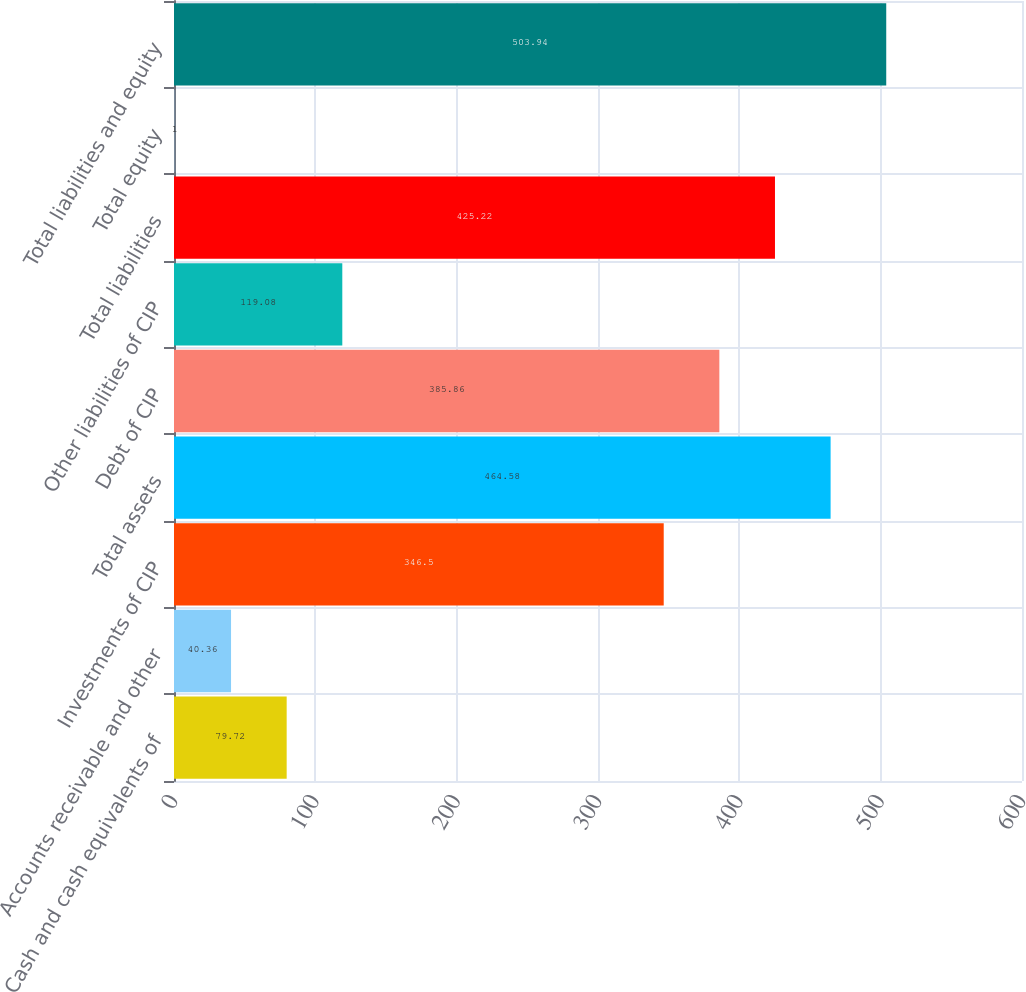Convert chart. <chart><loc_0><loc_0><loc_500><loc_500><bar_chart><fcel>Cash and cash equivalents of<fcel>Accounts receivable and other<fcel>Investments of CIP<fcel>Total assets<fcel>Debt of CIP<fcel>Other liabilities of CIP<fcel>Total liabilities<fcel>Total equity<fcel>Total liabilities and equity<nl><fcel>79.72<fcel>40.36<fcel>346.5<fcel>464.58<fcel>385.86<fcel>119.08<fcel>425.22<fcel>1<fcel>503.94<nl></chart> 